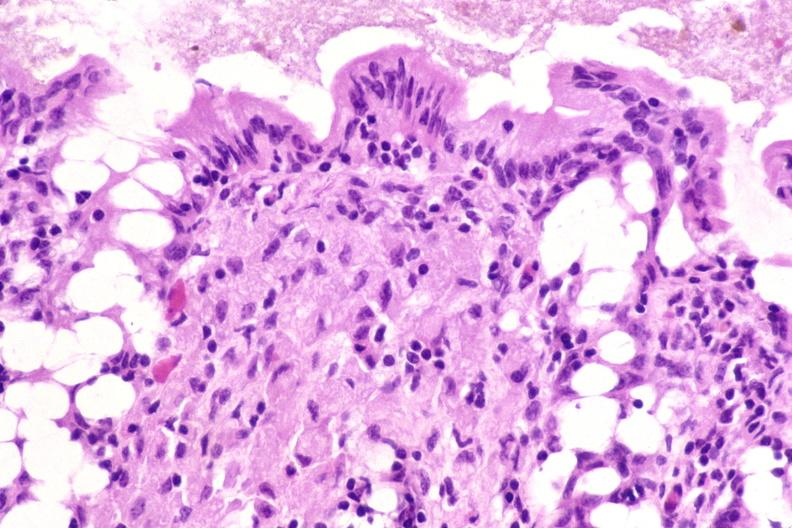what is present?
Answer the question using a single word or phrase. Gastrointestinal 